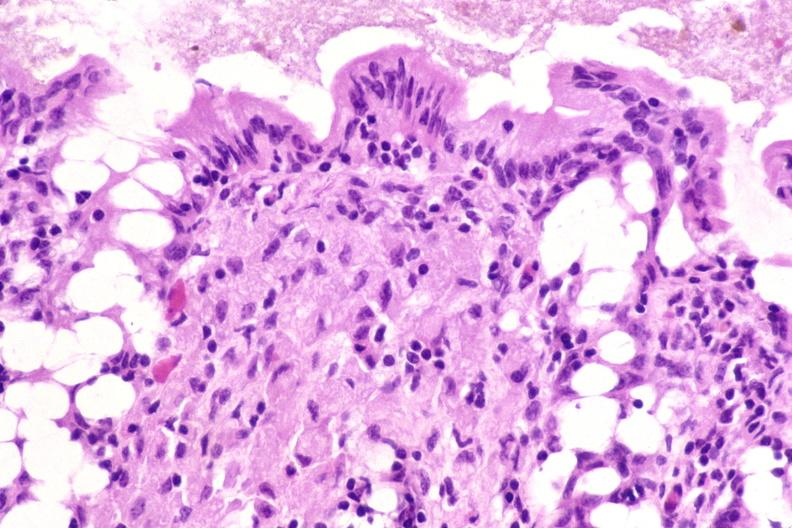what is present?
Answer the question using a single word or phrase. Gastrointestinal 